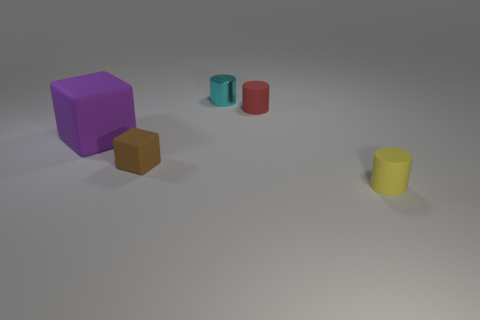Is there any other thing that has the same size as the purple object?
Keep it short and to the point. No. Are there any other things that are the same material as the cyan cylinder?
Provide a short and direct response. No. There is a red object that is the same shape as the small cyan thing; what material is it?
Give a very brief answer. Rubber. How many things are either things on the left side of the yellow thing or cylinders behind the tiny block?
Provide a short and direct response. 4. Do the tiny red rubber object and the small matte thing that is on the left side of the cyan object have the same shape?
Ensure brevity in your answer.  No. What shape is the tiny matte object on the right side of the rubber cylinder that is behind the block behind the tiny block?
Provide a short and direct response. Cylinder. How many other objects are the same material as the purple object?
Offer a very short reply. 3. How many objects are small metal objects that are to the left of the small yellow cylinder or cyan cylinders?
Your answer should be very brief. 1. There is a object that is on the left side of the small rubber object on the left side of the metallic cylinder; what is its shape?
Provide a succinct answer. Cube. There is a object behind the red rubber object; is its shape the same as the yellow matte thing?
Offer a terse response. Yes. 